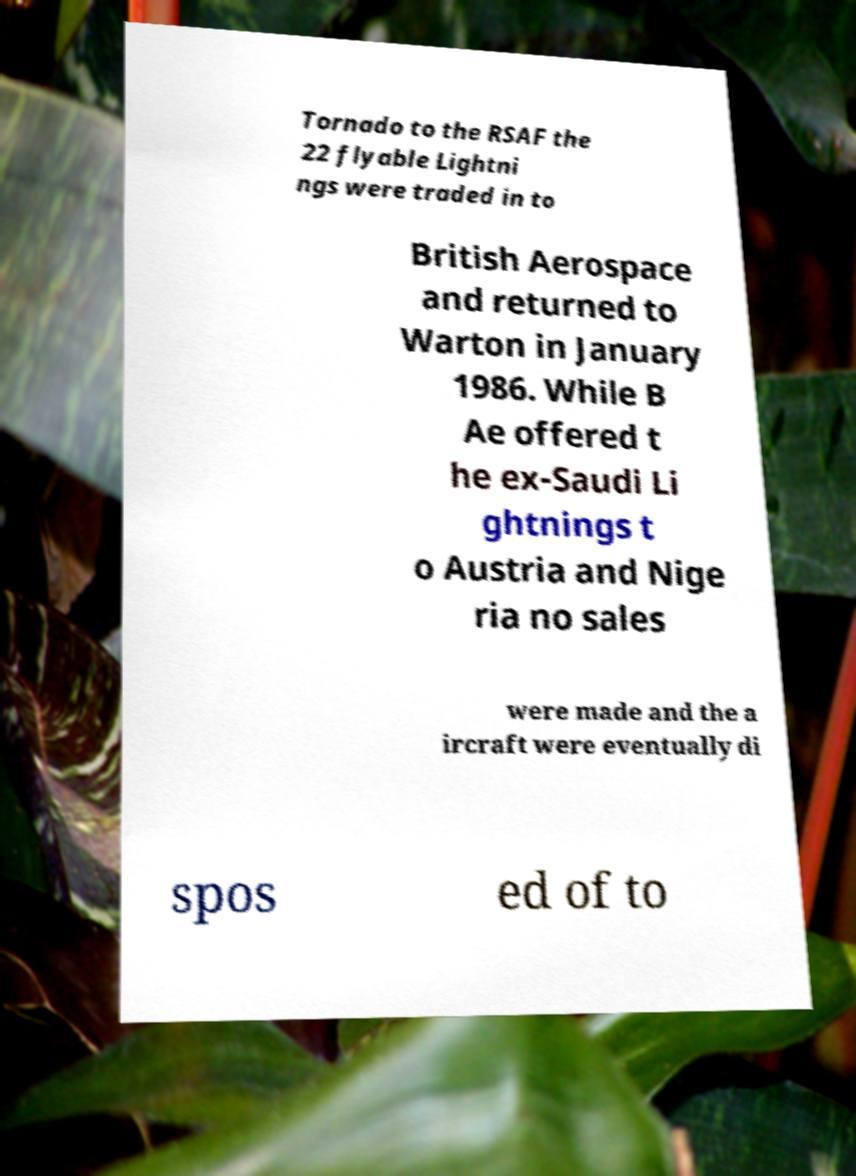There's text embedded in this image that I need extracted. Can you transcribe it verbatim? Tornado to the RSAF the 22 flyable Lightni ngs were traded in to British Aerospace and returned to Warton in January 1986. While B Ae offered t he ex-Saudi Li ghtnings t o Austria and Nige ria no sales were made and the a ircraft were eventually di spos ed of to 